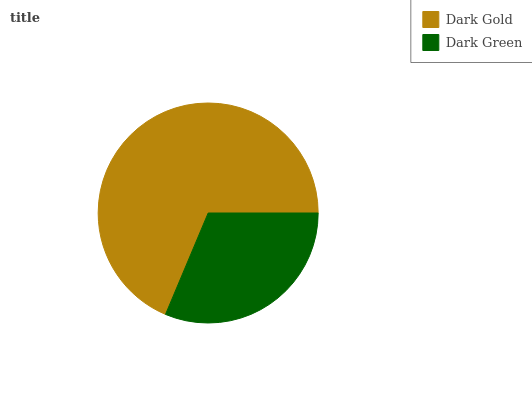Is Dark Green the minimum?
Answer yes or no. Yes. Is Dark Gold the maximum?
Answer yes or no. Yes. Is Dark Green the maximum?
Answer yes or no. No. Is Dark Gold greater than Dark Green?
Answer yes or no. Yes. Is Dark Green less than Dark Gold?
Answer yes or no. Yes. Is Dark Green greater than Dark Gold?
Answer yes or no. No. Is Dark Gold less than Dark Green?
Answer yes or no. No. Is Dark Gold the high median?
Answer yes or no. Yes. Is Dark Green the low median?
Answer yes or no. Yes. Is Dark Green the high median?
Answer yes or no. No. Is Dark Gold the low median?
Answer yes or no. No. 